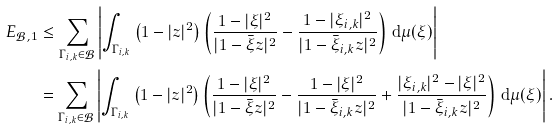Convert formula to latex. <formula><loc_0><loc_0><loc_500><loc_500>E _ { \mathcal { B } , 1 } & \leq \sum _ { \Gamma _ { i , k } \in \mathcal { B } } \left | \int _ { \Gamma _ { i , k } } \left ( 1 - | z | ^ { 2 } \right ) \left ( \frac { 1 - | \xi | ^ { 2 } } { | 1 - \bar { \xi } z | ^ { 2 } } - \frac { 1 - | \xi _ { i , k } | ^ { 2 } } { | 1 - \bar { \xi } _ { i , k } z | ^ { 2 } } \right ) \, \mathrm d \mu ( \xi ) \right | \\ & = \sum _ { \Gamma _ { i , k } \in \mathcal { B } } \left | \int _ { \Gamma _ { i , k } } \left ( 1 - | z | ^ { 2 } \right ) \left ( \frac { 1 - | \xi | ^ { 2 } } { | 1 - \bar { \xi } z | ^ { 2 } } - \frac { 1 - | \xi | ^ { 2 } } { | 1 - \bar { \xi } _ { i , k } z | ^ { 2 } } + \frac { | \xi _ { i , k } | ^ { 2 } - | \xi | ^ { 2 } } { | 1 - \bar { \xi } _ { i , k } z | ^ { 2 } } \right ) \, \mathrm d \mu ( \xi ) \right | .</formula> 